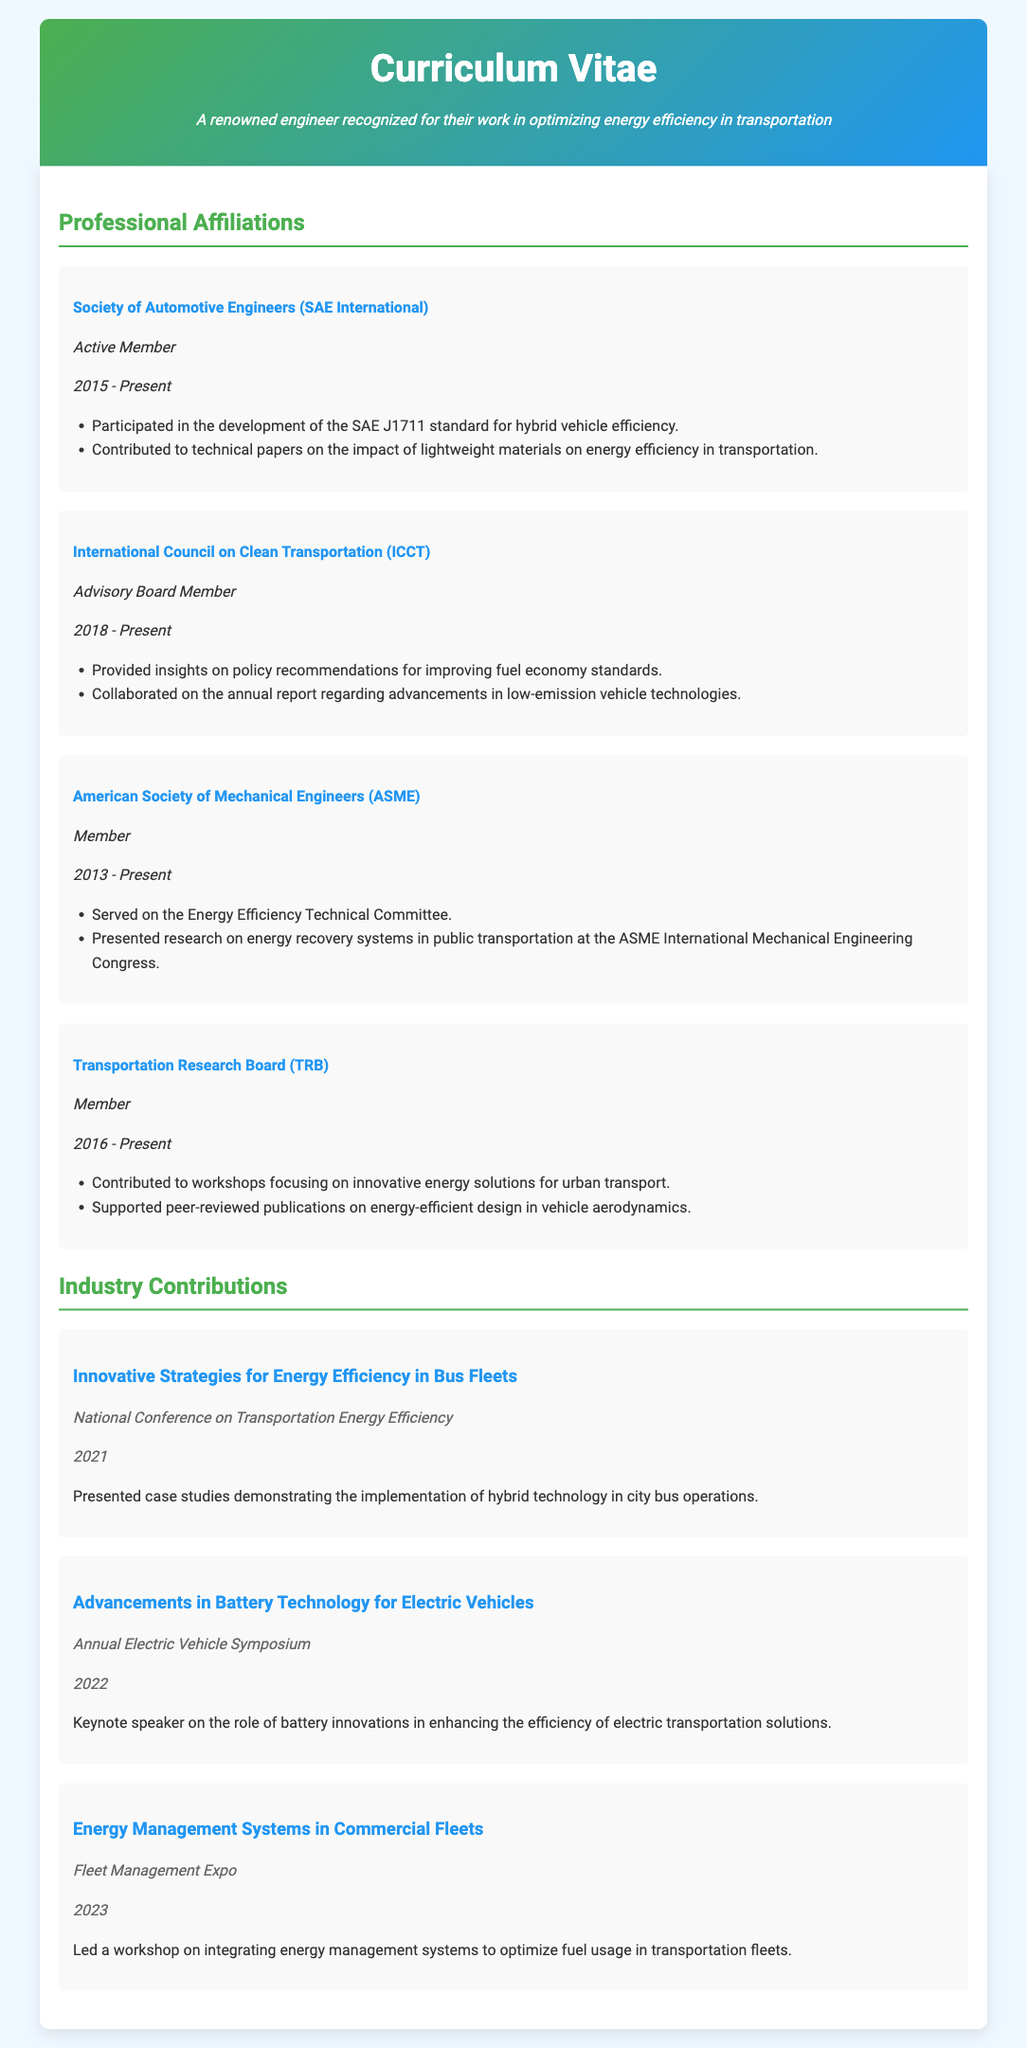What is the name of the first organization listed in the professional affiliations? The first organization listed is the Society of Automotive Engineers (SAE International).
Answer: Society of Automotive Engineers (SAE International) What role does the individual hold at the International Council on Clean Transportation? The individual's role at the International Council on Clean Transportation is Advisory Board Member.
Answer: Advisory Board Member In which year did the individual start being a member of the American Society of Mechanical Engineers? The individual became a member of the American Society of Mechanical Engineers in 2013.
Answer: 2013 How many years has the individual been a member of the Transportation Research Board? The individual has been a member of the Transportation Research Board since 2016, which is 7 years as of now (2023).
Answer: 7 years What was the title of the workshop led by the individual at the Fleet Management Expo? The title of the workshop led was "Energy Management Systems in Commercial Fleets."
Answer: Energy Management Systems in Commercial Fleets What is the focus of the case studies presented at the National Conference on Transportation Energy Efficiency? The focus of the case studies was on the implementation of hybrid technology in city bus operations.
Answer: Hybrid technology in city bus operations Which conference featured the keynote speech on advancements in battery technology? The keynote speech on advancements in battery technology was featured at the Annual Electric Vehicle Symposium.
Answer: Annual Electric Vehicle Symposium What is the main topic addressed in the contributed workshops of the Transportation Research Board? The main topic addressed in the workshops is innovative energy solutions for urban transport.
Answer: Innovative energy solutions for urban transport 